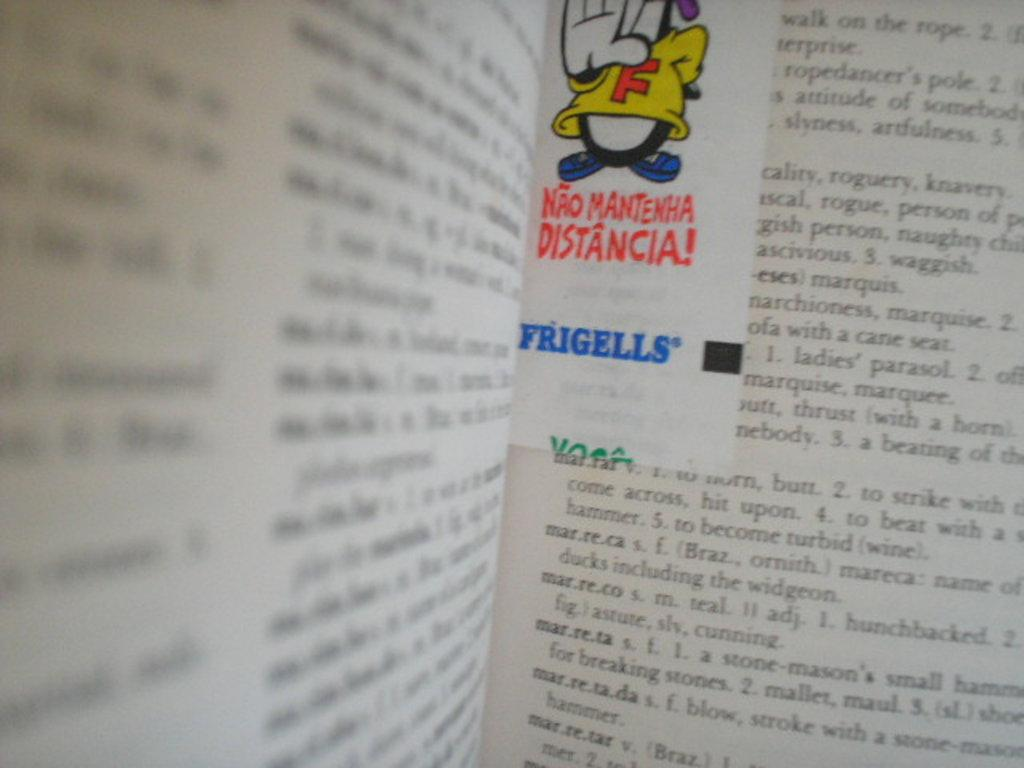Provide a one-sentence caption for the provided image. An open dictionary showing the words marreca, marreco, etc. 